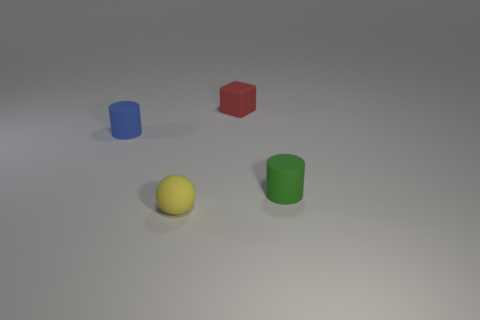Are there any colors that the objects share in common? No, the objects each have a unique color. The colors visible are blue, red, yellow, and green. There is no overlap in color among these objects, providing a clear visual distinction between each one. How might the differences in color affect our perception of the objects? The distinct colors can influence our perception by making each object stand out individually, which might help in quickly distinguishing and identifying them. Colors can also evoke different emotional responses or associations, potentially affecting how we perceive the objects' utility or significance. 